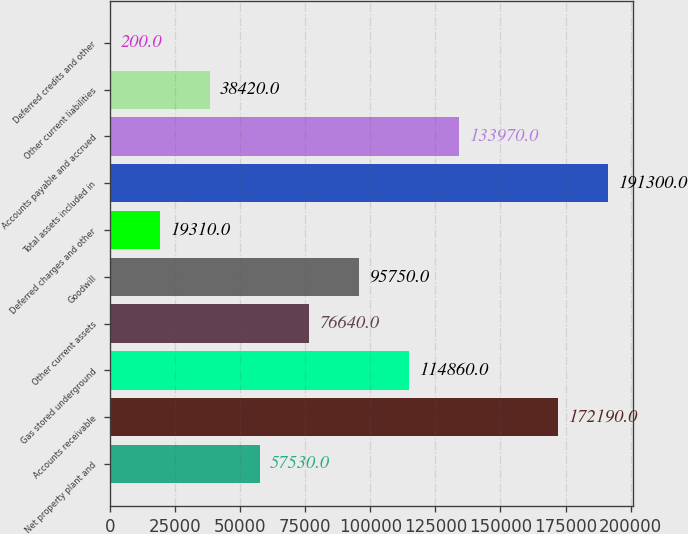<chart> <loc_0><loc_0><loc_500><loc_500><bar_chart><fcel>Net property plant and<fcel>Accounts receivable<fcel>Gas stored underground<fcel>Other current assets<fcel>Goodwill<fcel>Deferred charges and other<fcel>Total assets included in<fcel>Accounts payable and accrued<fcel>Other current liabilities<fcel>Deferred credits and other<nl><fcel>57530<fcel>172190<fcel>114860<fcel>76640<fcel>95750<fcel>19310<fcel>191300<fcel>133970<fcel>38420<fcel>200<nl></chart> 